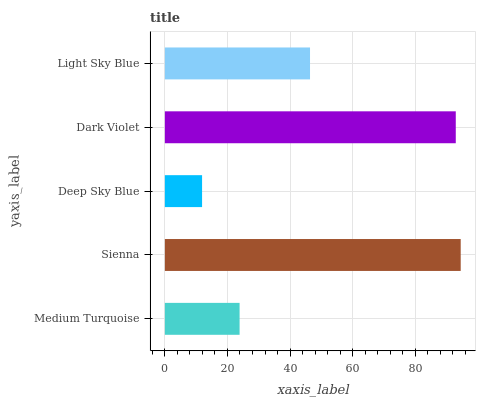Is Deep Sky Blue the minimum?
Answer yes or no. Yes. Is Sienna the maximum?
Answer yes or no. Yes. Is Sienna the minimum?
Answer yes or no. No. Is Deep Sky Blue the maximum?
Answer yes or no. No. Is Sienna greater than Deep Sky Blue?
Answer yes or no. Yes. Is Deep Sky Blue less than Sienna?
Answer yes or no. Yes. Is Deep Sky Blue greater than Sienna?
Answer yes or no. No. Is Sienna less than Deep Sky Blue?
Answer yes or no. No. Is Light Sky Blue the high median?
Answer yes or no. Yes. Is Light Sky Blue the low median?
Answer yes or no. Yes. Is Deep Sky Blue the high median?
Answer yes or no. No. Is Sienna the low median?
Answer yes or no. No. 